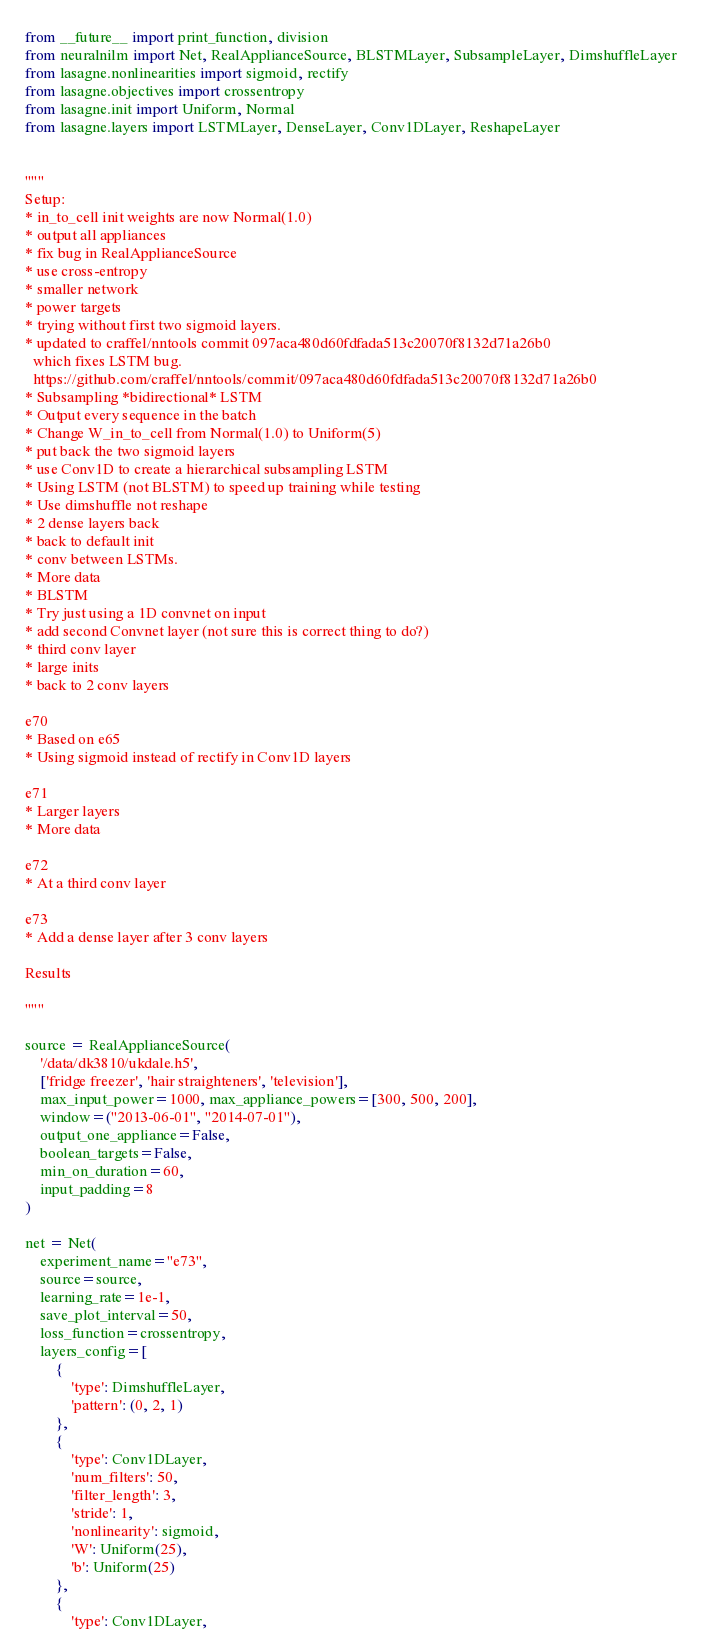Convert code to text. <code><loc_0><loc_0><loc_500><loc_500><_Python_>from __future__ import print_function, division
from neuralnilm import Net, RealApplianceSource, BLSTMLayer, SubsampleLayer, DimshuffleLayer
from lasagne.nonlinearities import sigmoid, rectify
from lasagne.objectives import crossentropy
from lasagne.init import Uniform, Normal
from lasagne.layers import LSTMLayer, DenseLayer, Conv1DLayer, ReshapeLayer


"""
Setup:
* in_to_cell init weights are now Normal(1.0)
* output all appliances
* fix bug in RealApplianceSource
* use cross-entropy
* smaller network
* power targets
* trying without first two sigmoid layers.
* updated to craffel/nntools commit 097aca480d60fdfada513c20070f8132d71a26b0 
  which fixes LSTM bug.
  https://github.com/craffel/nntools/commit/097aca480d60fdfada513c20070f8132d71a26b0
* Subsampling *bidirectional* LSTM
* Output every sequence in the batch
* Change W_in_to_cell from Normal(1.0) to Uniform(5)
* put back the two sigmoid layers
* use Conv1D to create a hierarchical subsampling LSTM
* Using LSTM (not BLSTM) to speed up training while testing
* Use dimshuffle not reshape
* 2 dense layers back
* back to default init
* conv between LSTMs.
* More data
* BLSTM
* Try just using a 1D convnet on input
* add second Convnet layer (not sure this is correct thing to do?)
* third conv layer
* large inits
* back to 2 conv layers

e70
* Based on e65
* Using sigmoid instead of rectify in Conv1D layers

e71
* Larger layers
* More data

e72
* At a third conv layer

e73
* Add a dense layer after 3 conv layers

Results

"""

source = RealApplianceSource(
    '/data/dk3810/ukdale.h5', 
    ['fridge freezer', 'hair straighteners', 'television'],
    max_input_power=1000, max_appliance_powers=[300, 500, 200],
    window=("2013-06-01", "2014-07-01"),
    output_one_appliance=False,
    boolean_targets=False,
    min_on_duration=60,
    input_padding=8
)

net = Net(
    experiment_name="e73",
    source=source,
    learning_rate=1e-1,
    save_plot_interval=50,
    loss_function=crossentropy,
    layers_config=[
        {
            'type': DimshuffleLayer,
            'pattern': (0, 2, 1)
        },
        {
            'type': Conv1DLayer,
            'num_filters': 50,
            'filter_length': 3,
            'stride': 1,
            'nonlinearity': sigmoid,
            'W': Uniform(25),
            'b': Uniform(25)
        },
        {
            'type': Conv1DLayer,</code> 